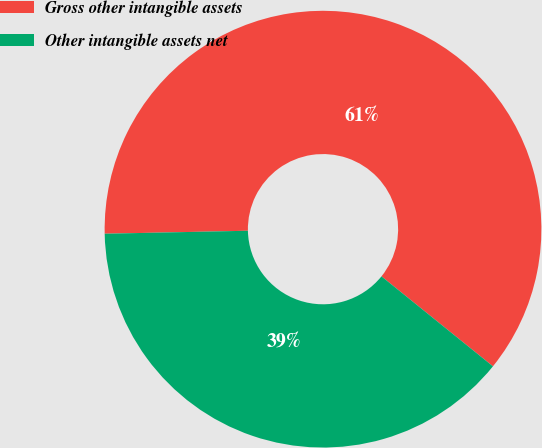<chart> <loc_0><loc_0><loc_500><loc_500><pie_chart><fcel>Gross other intangible assets<fcel>Other intangible assets net<nl><fcel>61.14%<fcel>38.86%<nl></chart> 